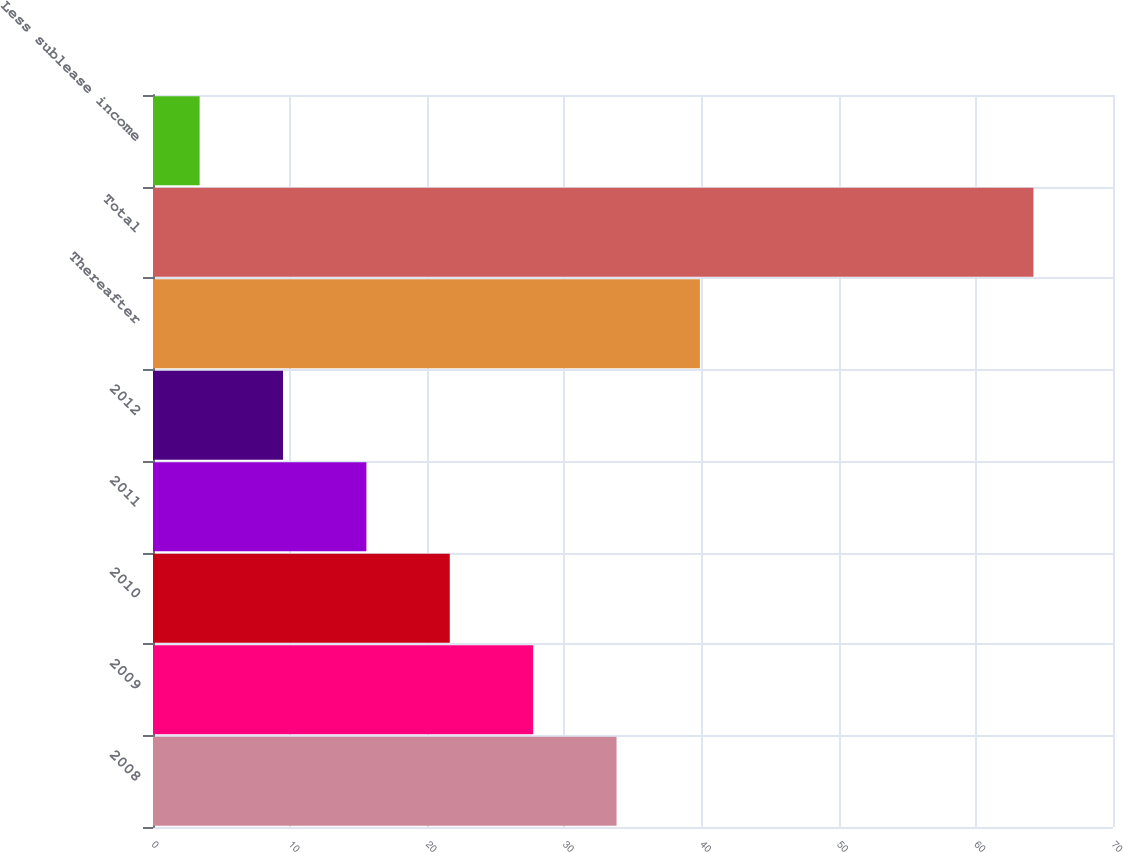<chart> <loc_0><loc_0><loc_500><loc_500><bar_chart><fcel>2008<fcel>2009<fcel>2010<fcel>2011<fcel>2012<fcel>Thereafter<fcel>Total<fcel>Less sublease income<nl><fcel>33.8<fcel>27.72<fcel>21.64<fcel>15.56<fcel>9.48<fcel>39.88<fcel>64.2<fcel>3.4<nl></chart> 